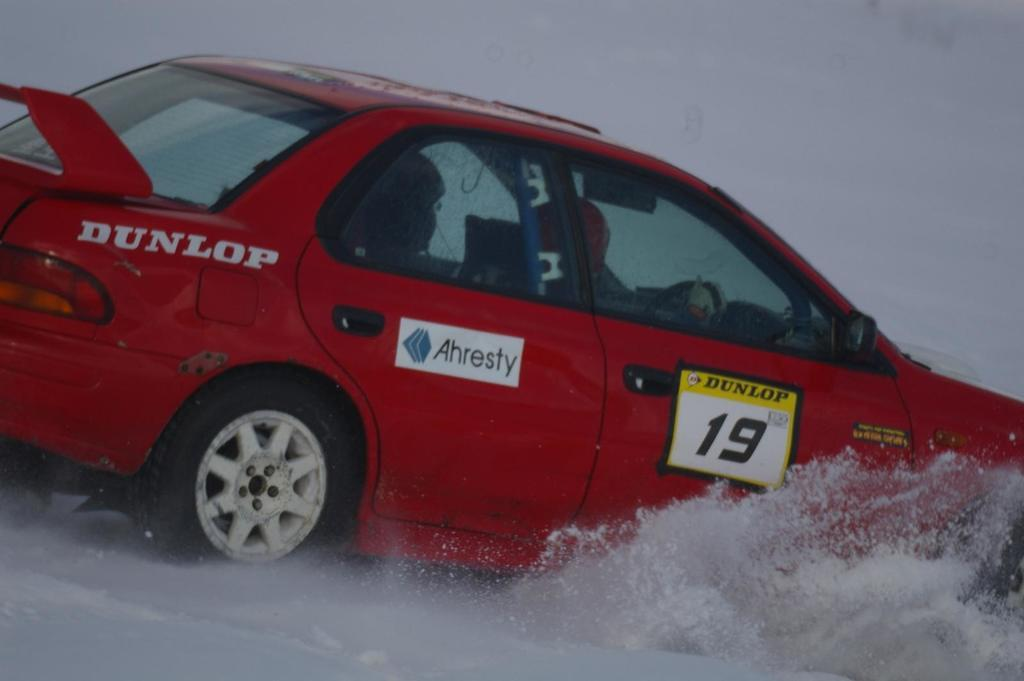What is the main subject of the image? There is a person in the image. What is the person doing in the image? The person is driving a car. What color is the car? The car is red in color. What is the terrain like in the image? The car is on the snow. What type of wood is being used to build the sack in the image? There is no wood or sack present in the image. What does the person need to do in order to drive the car more efficiently in the snow? The image does not provide information about the person's driving skills or the need for any specific actions to drive more efficiently in the snow. 